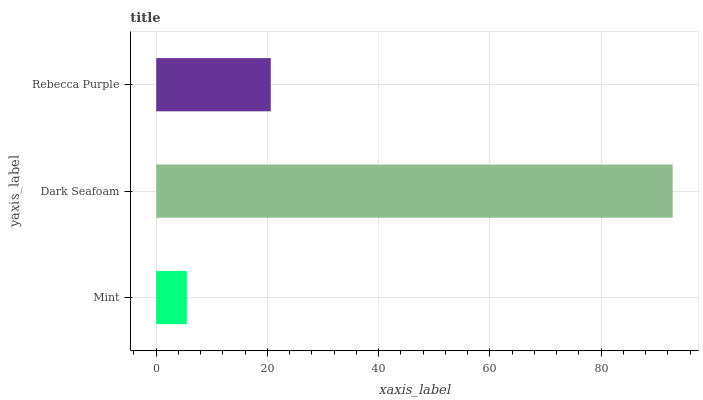Is Mint the minimum?
Answer yes or no. Yes. Is Dark Seafoam the maximum?
Answer yes or no. Yes. Is Rebecca Purple the minimum?
Answer yes or no. No. Is Rebecca Purple the maximum?
Answer yes or no. No. Is Dark Seafoam greater than Rebecca Purple?
Answer yes or no. Yes. Is Rebecca Purple less than Dark Seafoam?
Answer yes or no. Yes. Is Rebecca Purple greater than Dark Seafoam?
Answer yes or no. No. Is Dark Seafoam less than Rebecca Purple?
Answer yes or no. No. Is Rebecca Purple the high median?
Answer yes or no. Yes. Is Rebecca Purple the low median?
Answer yes or no. Yes. Is Dark Seafoam the high median?
Answer yes or no. No. Is Mint the low median?
Answer yes or no. No. 